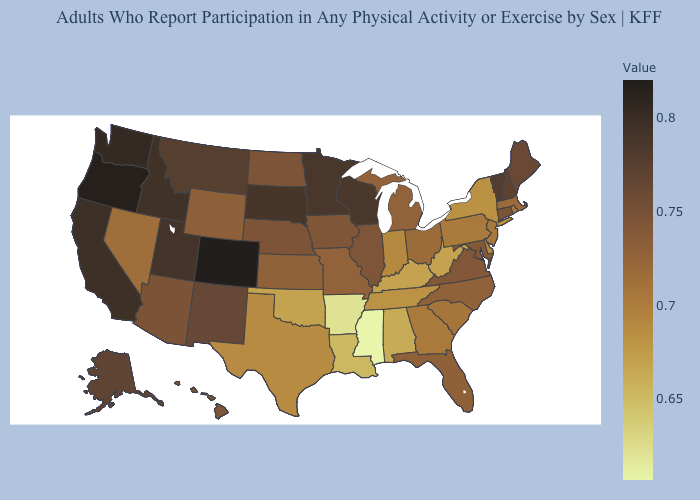Which states hav the highest value in the Northeast?
Concise answer only. Vermont. Is the legend a continuous bar?
Write a very short answer. Yes. Among the states that border Pennsylvania , which have the lowest value?
Write a very short answer. West Virginia. 